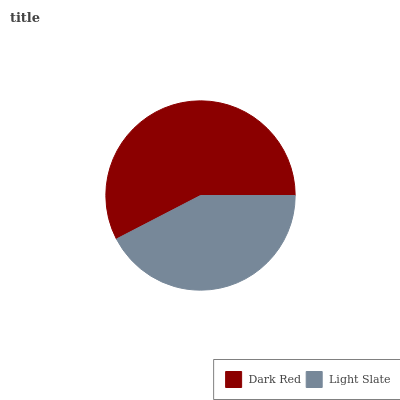Is Light Slate the minimum?
Answer yes or no. Yes. Is Dark Red the maximum?
Answer yes or no. Yes. Is Light Slate the maximum?
Answer yes or no. No. Is Dark Red greater than Light Slate?
Answer yes or no. Yes. Is Light Slate less than Dark Red?
Answer yes or no. Yes. Is Light Slate greater than Dark Red?
Answer yes or no. No. Is Dark Red less than Light Slate?
Answer yes or no. No. Is Dark Red the high median?
Answer yes or no. Yes. Is Light Slate the low median?
Answer yes or no. Yes. Is Light Slate the high median?
Answer yes or no. No. Is Dark Red the low median?
Answer yes or no. No. 